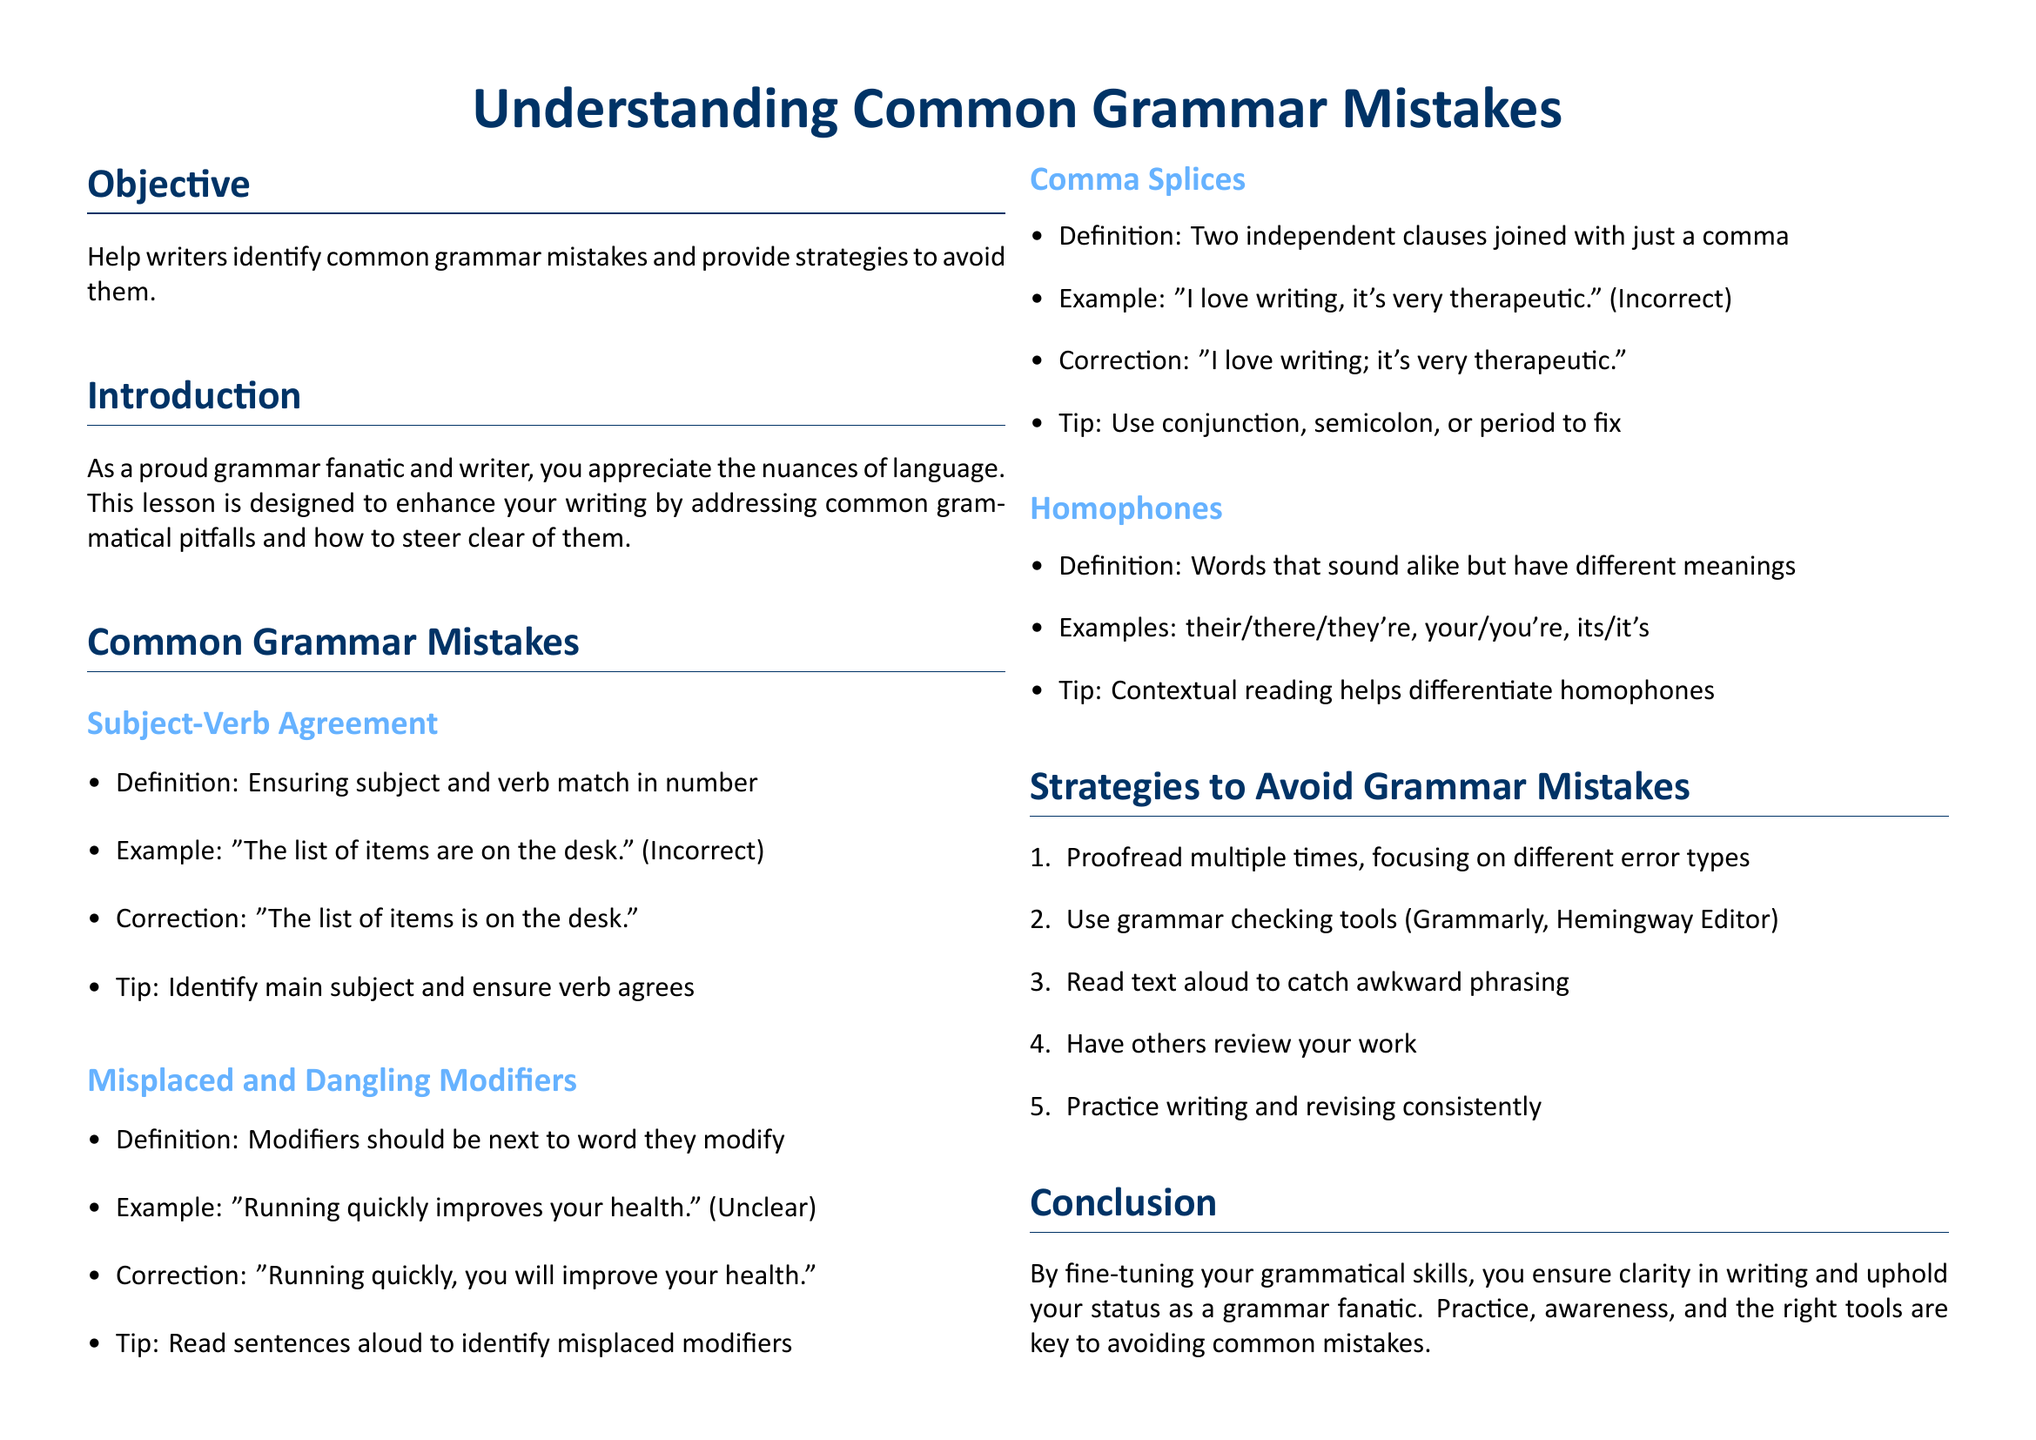What is the main objective of the lesson? The objective is to help writers identify common grammar mistakes and provide strategies to avoid them.
Answer: Help writers identify common grammar mistakes and provide strategies to avoid them What is an example of a common grammar mistake? The document lists several grammar mistakes; one example is subject-verb agreement.
Answer: Subject-Verb Agreement What correction should be made for the sentence "The list of items are on the desk"? The correction involves changing the verb to agree in number with the subject.
Answer: "The list of items is on the desk." Which tools are recommended for checking grammar? The lesson plan lists specific tools aimed at improving grammar accuracy.
Answer: Grammarly, Hemingway Editor What does the section on homophones address? The section provides information about words that sound alike but have different meanings.
Answer: Words that sound alike but have different meanings What is one strategy to avoid grammar mistakes mentioned in the document? The document provides several strategies, one of which is proofreading.
Answer: Proofread multiple times Which book is recommended in the resources section? The resources include specific books that focus on grammar.
Answer: Eats, Shoots & Leaves by Lynne Truss What is a benefit of reading text aloud? This method helps identify awkward phrasing, contributing to better grammar use.
Answer: To catch awkward phrasing What does "misplaced modifiers" refer to? This term is defined in the document in relation to sentence structure and clarity.
Answer: Modifiers should be next to the word they modify 